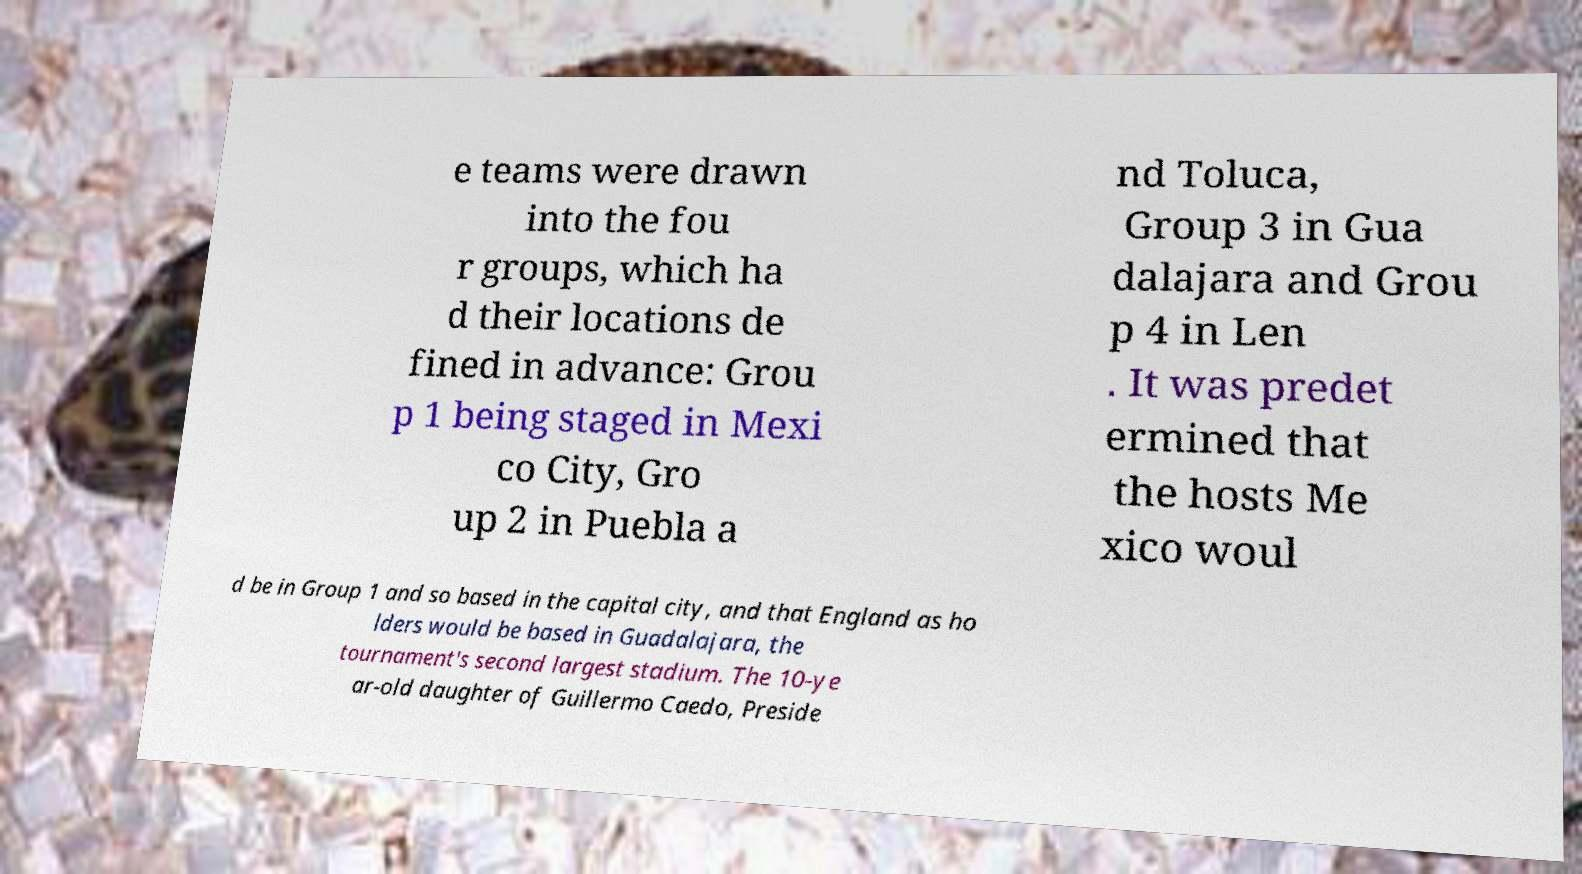What messages or text are displayed in this image? I need them in a readable, typed format. e teams were drawn into the fou r groups, which ha d their locations de fined in advance: Grou p 1 being staged in Mexi co City, Gro up 2 in Puebla a nd Toluca, Group 3 in Gua dalajara and Grou p 4 in Len . It was predet ermined that the hosts Me xico woul d be in Group 1 and so based in the capital city, and that England as ho lders would be based in Guadalajara, the tournament's second largest stadium. The 10-ye ar-old daughter of Guillermo Caedo, Preside 